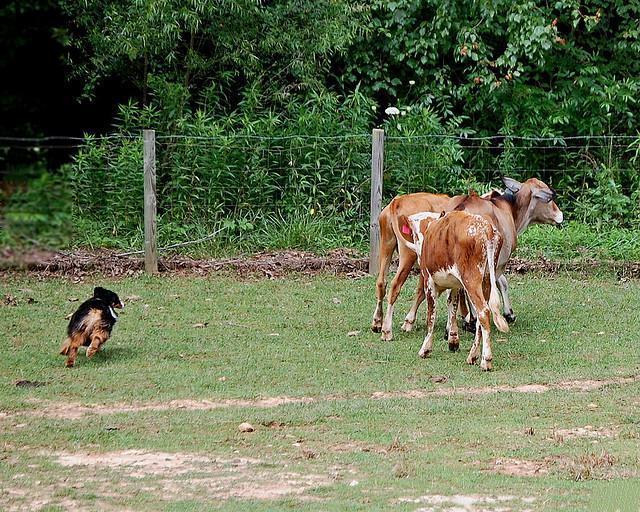How many cows are there?
Give a very brief answer. 2. 